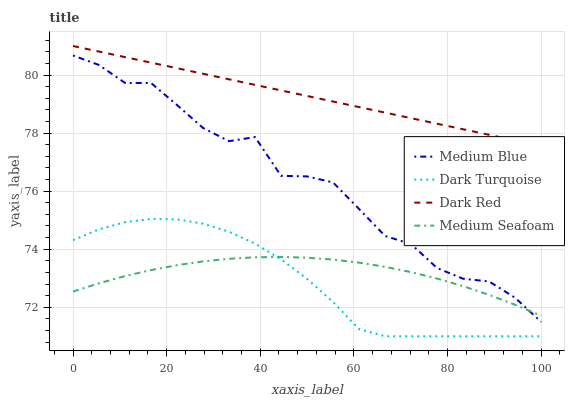Does Dark Turquoise have the minimum area under the curve?
Answer yes or no. Yes. Does Dark Red have the maximum area under the curve?
Answer yes or no. Yes. Does Medium Blue have the minimum area under the curve?
Answer yes or no. No. Does Medium Blue have the maximum area under the curve?
Answer yes or no. No. Is Dark Red the smoothest?
Answer yes or no. Yes. Is Medium Blue the roughest?
Answer yes or no. Yes. Is Medium Seafoam the smoothest?
Answer yes or no. No. Is Medium Seafoam the roughest?
Answer yes or no. No. Does Medium Blue have the lowest value?
Answer yes or no. No. Does Dark Red have the highest value?
Answer yes or no. Yes. Does Medium Blue have the highest value?
Answer yes or no. No. Is Dark Turquoise less than Medium Blue?
Answer yes or no. Yes. Is Medium Blue greater than Dark Turquoise?
Answer yes or no. Yes. Does Medium Seafoam intersect Medium Blue?
Answer yes or no. Yes. Is Medium Seafoam less than Medium Blue?
Answer yes or no. No. Is Medium Seafoam greater than Medium Blue?
Answer yes or no. No. Does Dark Turquoise intersect Medium Blue?
Answer yes or no. No. 